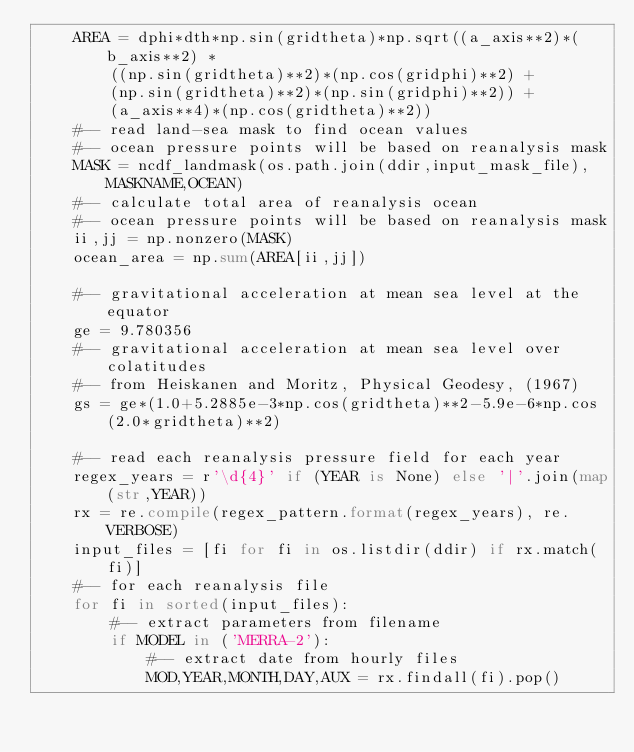<code> <loc_0><loc_0><loc_500><loc_500><_Python_>    AREA = dphi*dth*np.sin(gridtheta)*np.sqrt((a_axis**2)*(b_axis**2) *
        ((np.sin(gridtheta)**2)*(np.cos(gridphi)**2) +
        (np.sin(gridtheta)**2)*(np.sin(gridphi)**2)) +
        (a_axis**4)*(np.cos(gridtheta)**2))
    #-- read land-sea mask to find ocean values
    #-- ocean pressure points will be based on reanalysis mask
    MASK = ncdf_landmask(os.path.join(ddir,input_mask_file),MASKNAME,OCEAN)
    #-- calculate total area of reanalysis ocean
    #-- ocean pressure points will be based on reanalysis mask
    ii,jj = np.nonzero(MASK)
    ocean_area = np.sum(AREA[ii,jj])

    #-- gravitational acceleration at mean sea level at the equator
    ge = 9.780356
    #-- gravitational acceleration at mean sea level over colatitudes
    #-- from Heiskanen and Moritz, Physical Geodesy, (1967)
    gs = ge*(1.0+5.2885e-3*np.cos(gridtheta)**2-5.9e-6*np.cos(2.0*gridtheta)**2)

    #-- read each reanalysis pressure field for each year
    regex_years = r'\d{4}' if (YEAR is None) else '|'.join(map(str,YEAR))
    rx = re.compile(regex_pattern.format(regex_years), re.VERBOSE)
    input_files = [fi for fi in os.listdir(ddir) if rx.match(fi)]
    #-- for each reanalysis file
    for fi in sorted(input_files):
        #-- extract parameters from filename
        if MODEL in ('MERRA-2'):
            #-- extract date from hourly files
            MOD,YEAR,MONTH,DAY,AUX = rx.findall(fi).pop()</code> 